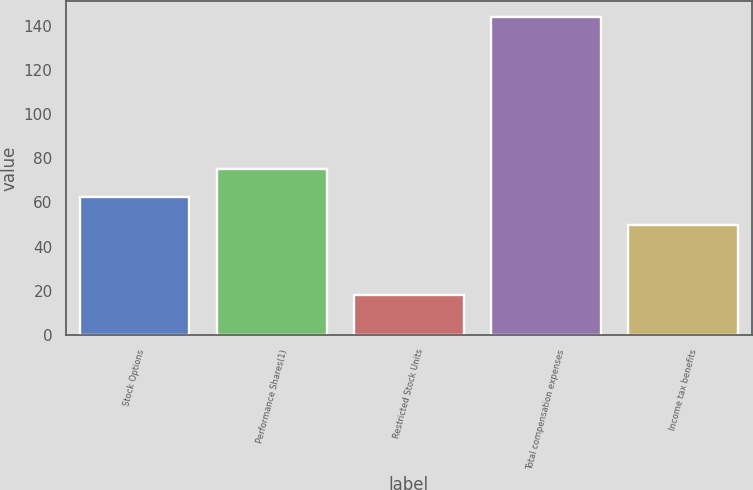Convert chart to OTSL. <chart><loc_0><loc_0><loc_500><loc_500><bar_chart><fcel>Stock Options<fcel>Performance Shares(1)<fcel>Restricted Stock Units<fcel>Total compensation expenses<fcel>Income tax benefits<nl><fcel>62.6<fcel>75.2<fcel>18<fcel>144<fcel>50<nl></chart> 